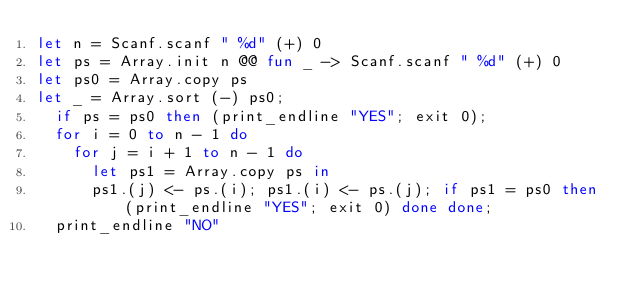<code> <loc_0><loc_0><loc_500><loc_500><_OCaml_>let n = Scanf.scanf " %d" (+) 0
let ps = Array.init n @@ fun _ -> Scanf.scanf " %d" (+) 0
let ps0 = Array.copy ps
let _ = Array.sort (-) ps0;
  if ps = ps0 then (print_endline "YES"; exit 0);
  for i = 0 to n - 1 do
    for j = i + 1 to n - 1 do
      let ps1 = Array.copy ps in
      ps1.(j) <- ps.(i); ps1.(i) <- ps.(j); if ps1 = ps0 then (print_endline "YES"; exit 0) done done;
  print_endline "NO"</code> 